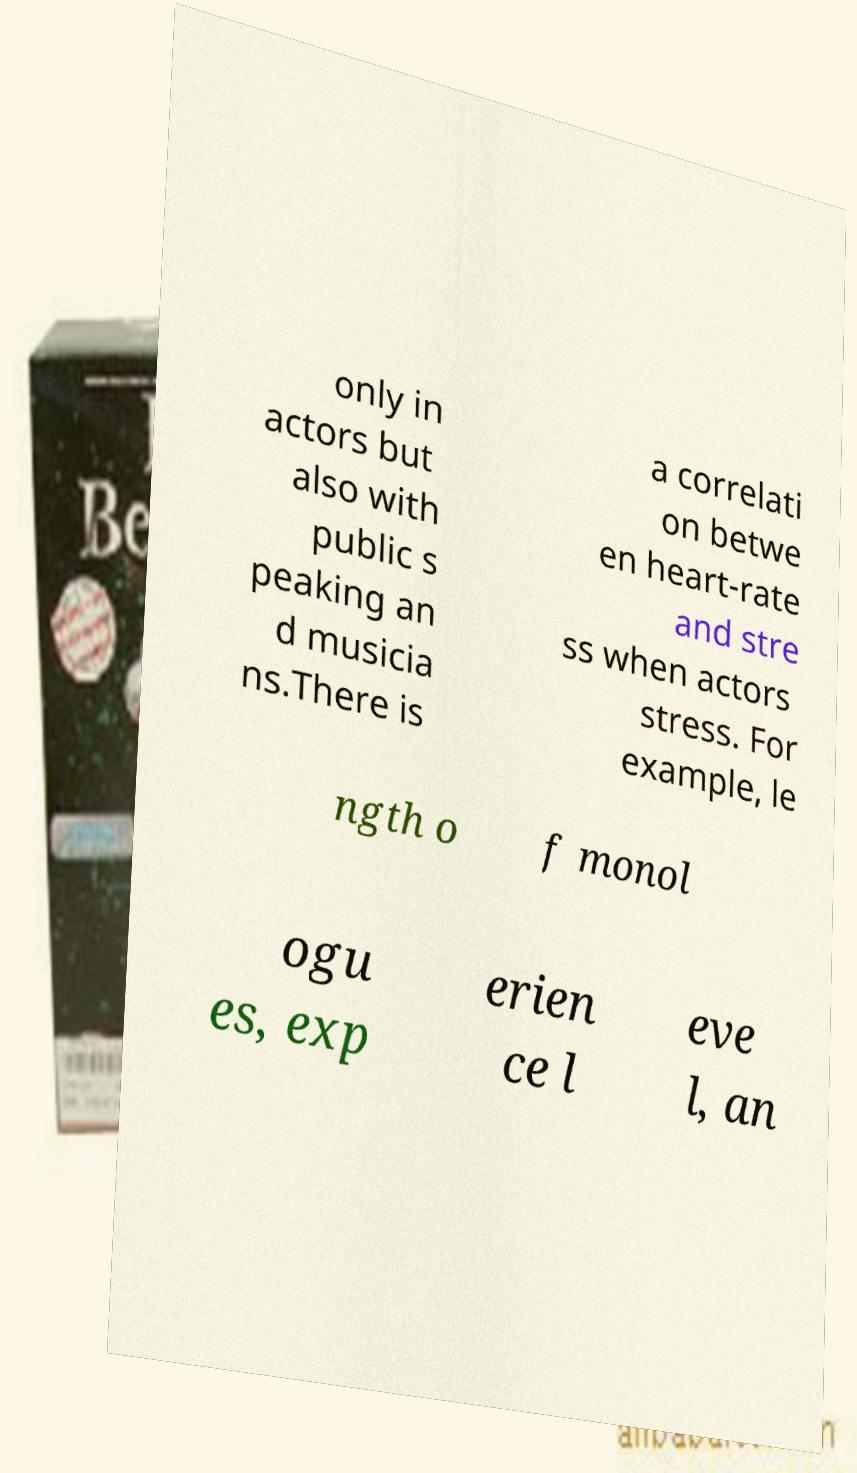Please identify and transcribe the text found in this image. only in actors but also with public s peaking an d musicia ns.There is a correlati on betwe en heart-rate and stre ss when actors stress. For example, le ngth o f monol ogu es, exp erien ce l eve l, an 